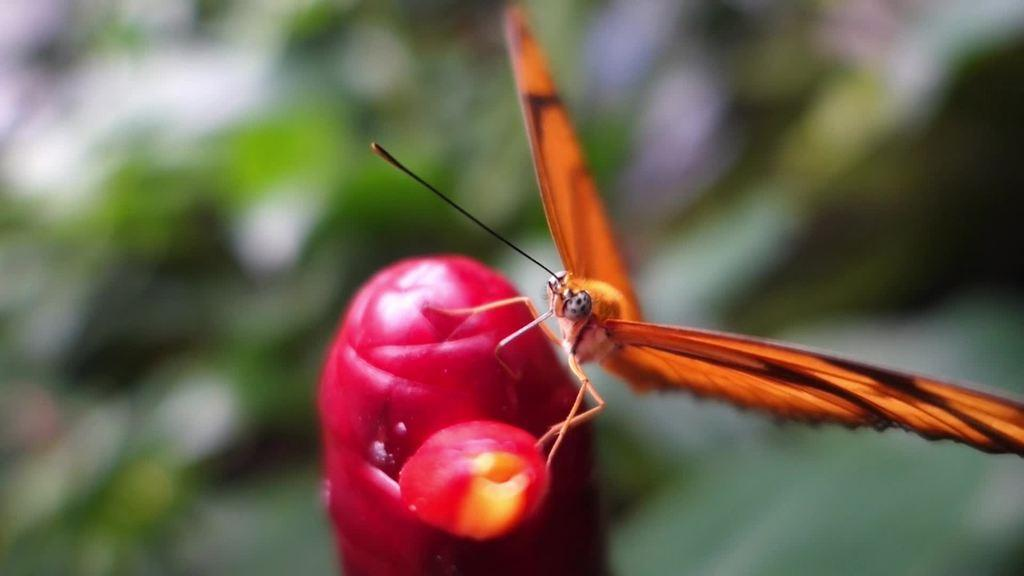What is the main subject of the image? There is a butterfly in the image. Where is the butterfly located? The butterfly is on a bud. Can you describe the background of the image? The background of the image is blurry. What type of cannon is present in the image? There is no cannon present in the image; it features a butterfly on a bud with a blurry background. 